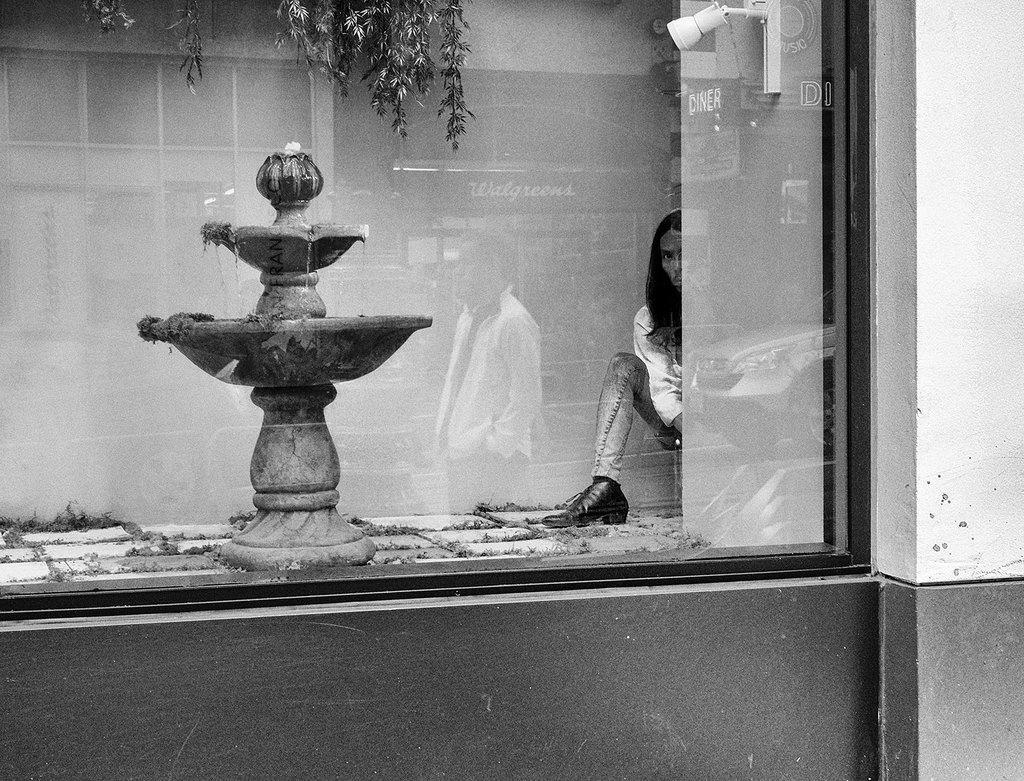Please provide a concise description of this image. This is a black and white image. In the image there is a wall with glass. Inside the glass there is a fountain on the ground. On the right side of the glass there is a man. At the top of the image there are leaves. On the glass there is a reflection of buildings and a man. 